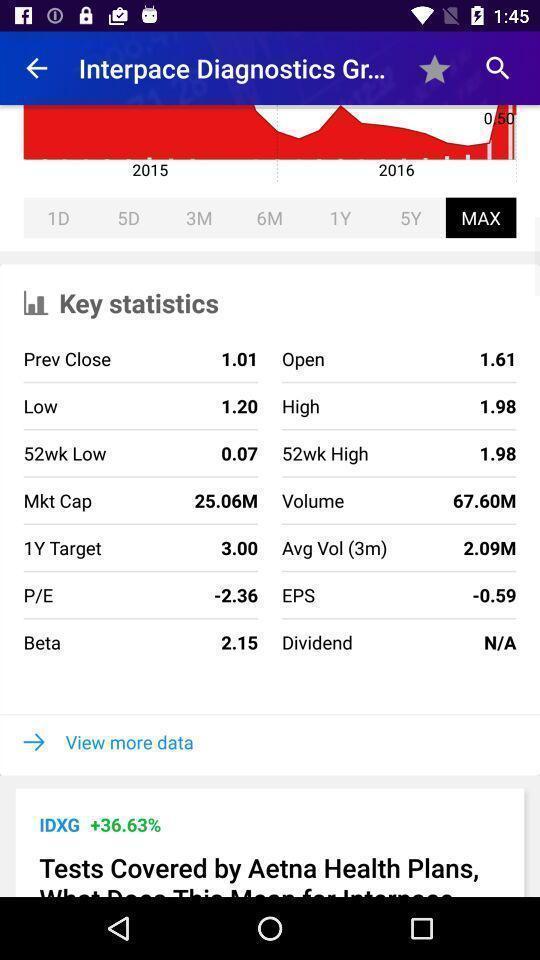Give me a summary of this screen capture. Page shows the key statistics of patient on health app. 